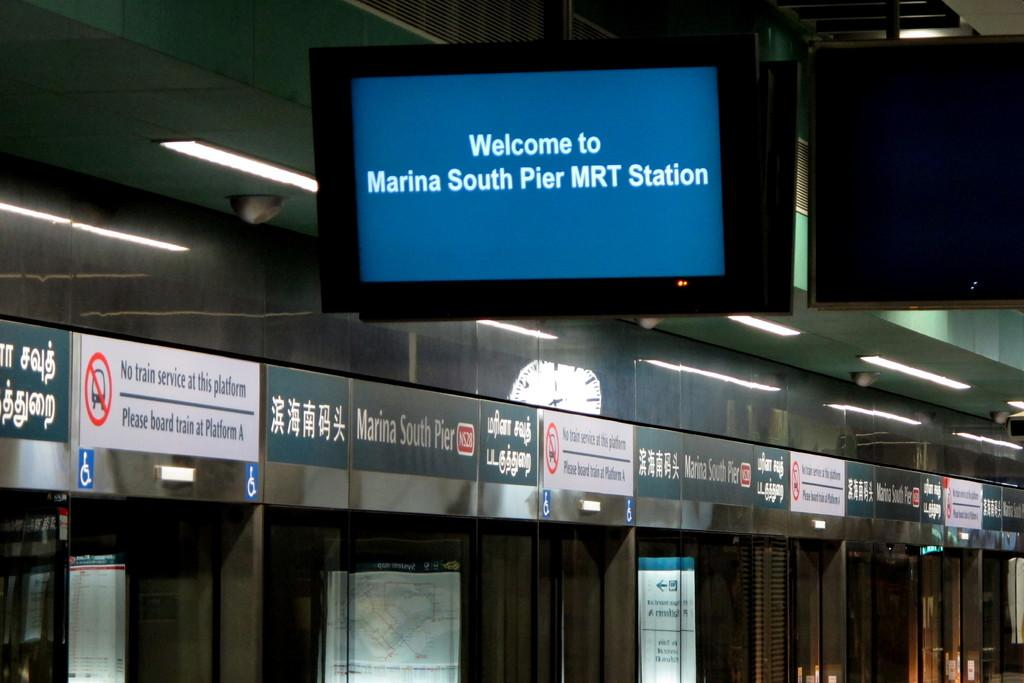<image>
Give a short and clear explanation of the subsequent image. A train station has a monitor hanging from the ceiling that says Welcome to Marina South Pier MRT Station. 